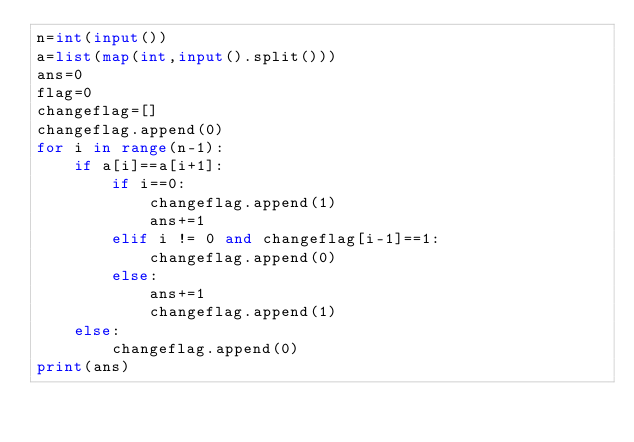Convert code to text. <code><loc_0><loc_0><loc_500><loc_500><_Python_>n=int(input())
a=list(map(int,input().split()))
ans=0
flag=0
changeflag=[]
changeflag.append(0)
for i in range(n-1):
    if a[i]==a[i+1]:
        if i==0:
            changeflag.append(1)
            ans+=1
        elif i != 0 and changeflag[i-1]==1:
            changeflag.append(0)
        else:
            ans+=1
            changeflag.append(1)
    else:
        changeflag.append(0)
print(ans)
</code> 